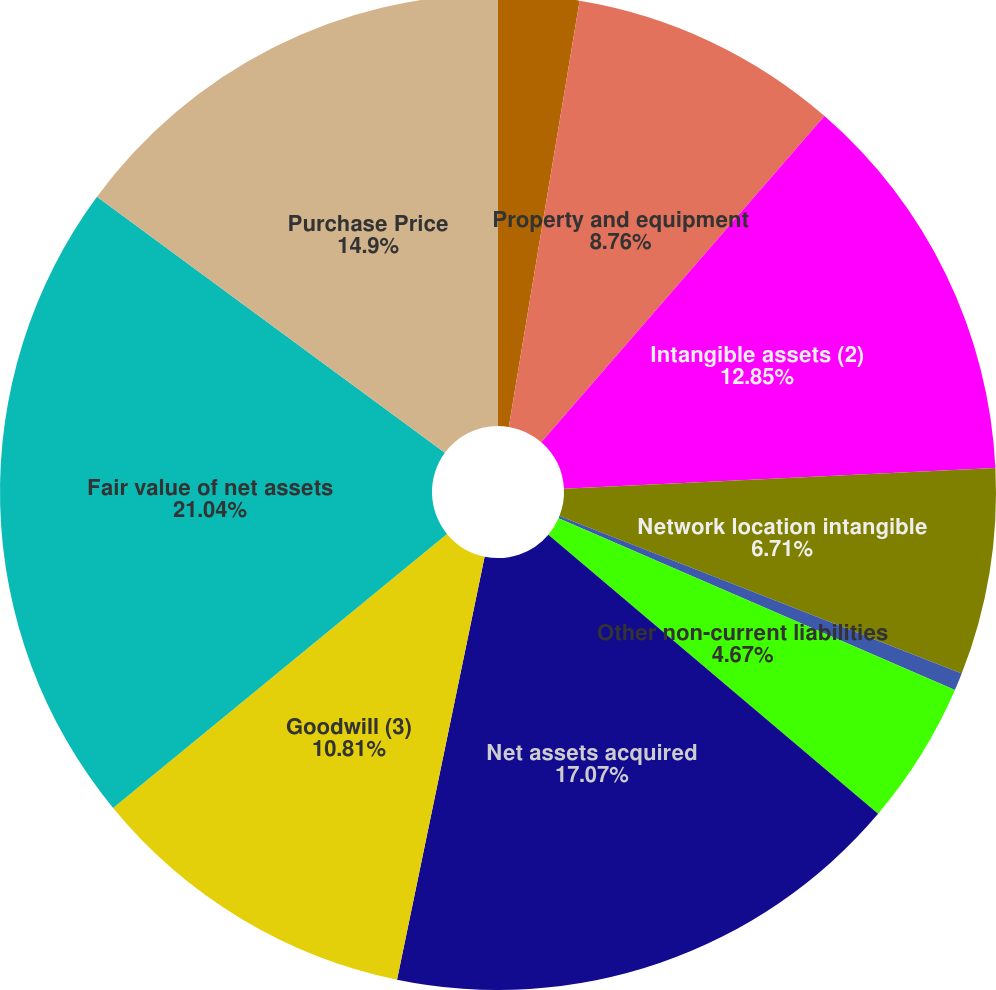<chart> <loc_0><loc_0><loc_500><loc_500><pie_chart><fcel>Current assets<fcel>Property and equipment<fcel>Intangible assets (2)<fcel>Network location intangible<fcel>Current liabilities<fcel>Other non-current liabilities<fcel>Net assets acquired<fcel>Goodwill (3)<fcel>Fair value of net assets<fcel>Purchase Price<nl><fcel>2.62%<fcel>8.76%<fcel>12.85%<fcel>6.71%<fcel>0.57%<fcel>4.67%<fcel>17.07%<fcel>10.81%<fcel>21.04%<fcel>14.9%<nl></chart> 